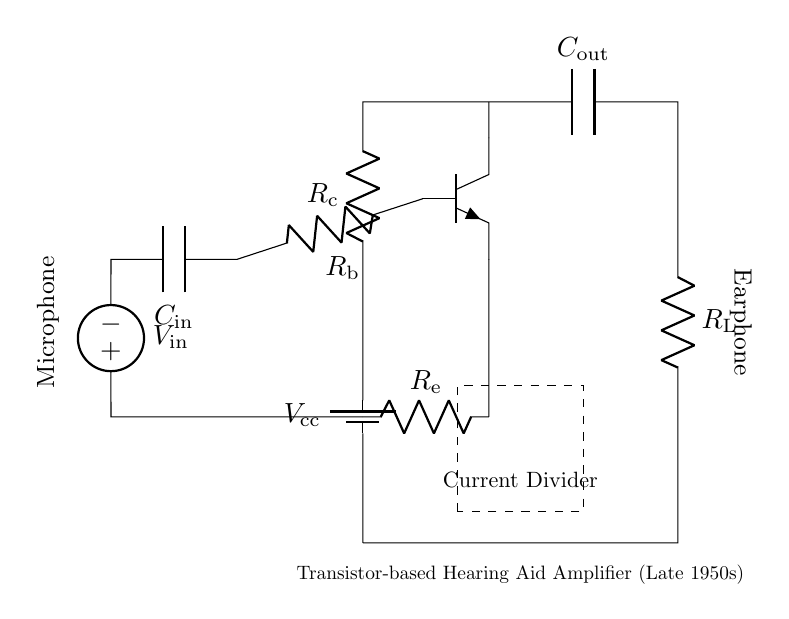What is the type of transistor used? The transistor is labeled as "npn," indicating it's a standard NPN type commonly used in amplifiers.
Answer: NPN What is the purpose of the microphone in this circuit? The microphone acts as the input device that converts sound waves into an electrical signal, feeding into the input of the amplifier.
Answer: Input signal conversion What are the component values connected to the output capacitor? The output capacitor connects to the load resistor labeled "R_L," which indicates the component through which the amplified sound will be delivered.
Answer: R_L What is the significance of the current divider in this circuit? The current divider allows the circuit to manage how the input signal splits into different pathways, affecting gain and performance. This is particularly relevant for setting biasing levels for the transistor.
Answer: Manage signal paths What are the connections on the left side of the transistor used for? The left side connections, specifically "R_b" and "C_in," are used for biasing the transistor and filtering the input signal, respectively, ensuring stable operation.
Answer: Biasing and filtering What is the voltage source labeled as "V_in"? "V_in" represents the voltage input signal from the microphone which activates the transistor to amplify the signal.
Answer: Input voltage signal 